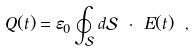Convert formula to latex. <formula><loc_0><loc_0><loc_500><loc_500>Q ( t ) = \varepsilon _ { 0 } \oint _ { \mathcal { S } } d \mathcal { S } \ { \cdot } \ { E } ( t ) \ ,</formula> 